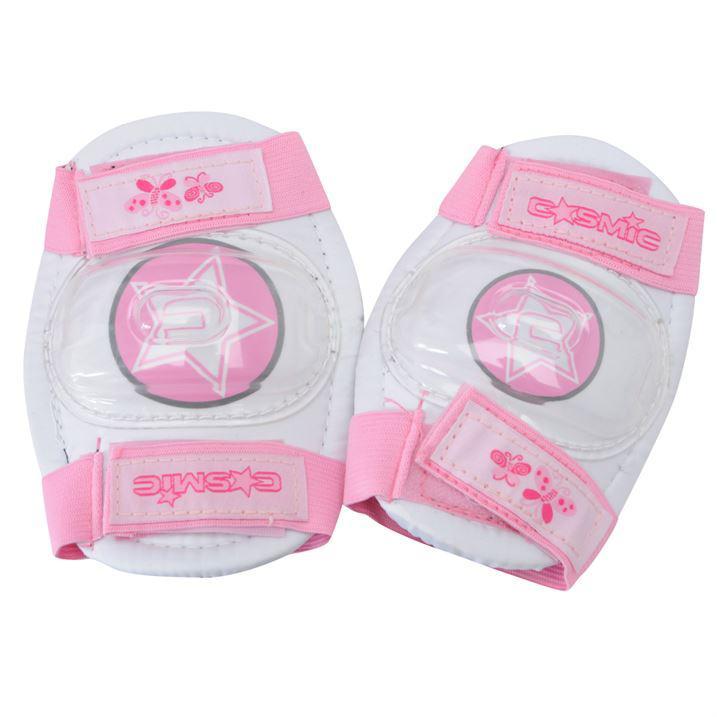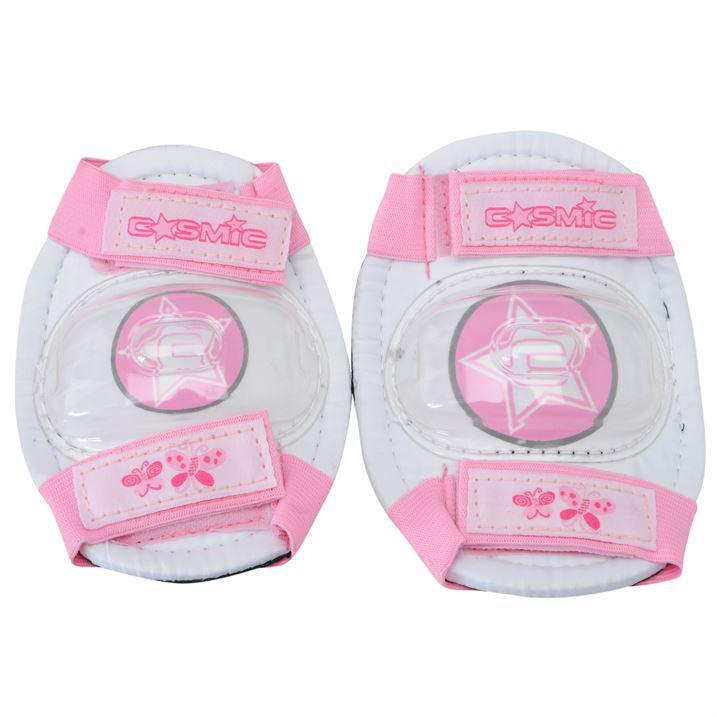The first image is the image on the left, the second image is the image on the right. Analyze the images presented: Is the assertion "In at least one of the images, we see only knee pads; no elbow pads or gloves." valid? Answer yes or no. Yes. The first image is the image on the left, the second image is the image on the right. Analyze the images presented: Is the assertion "There are pink elbow or knee pads with pink writing across the top of each of pad." valid? Answer yes or no. Yes. 